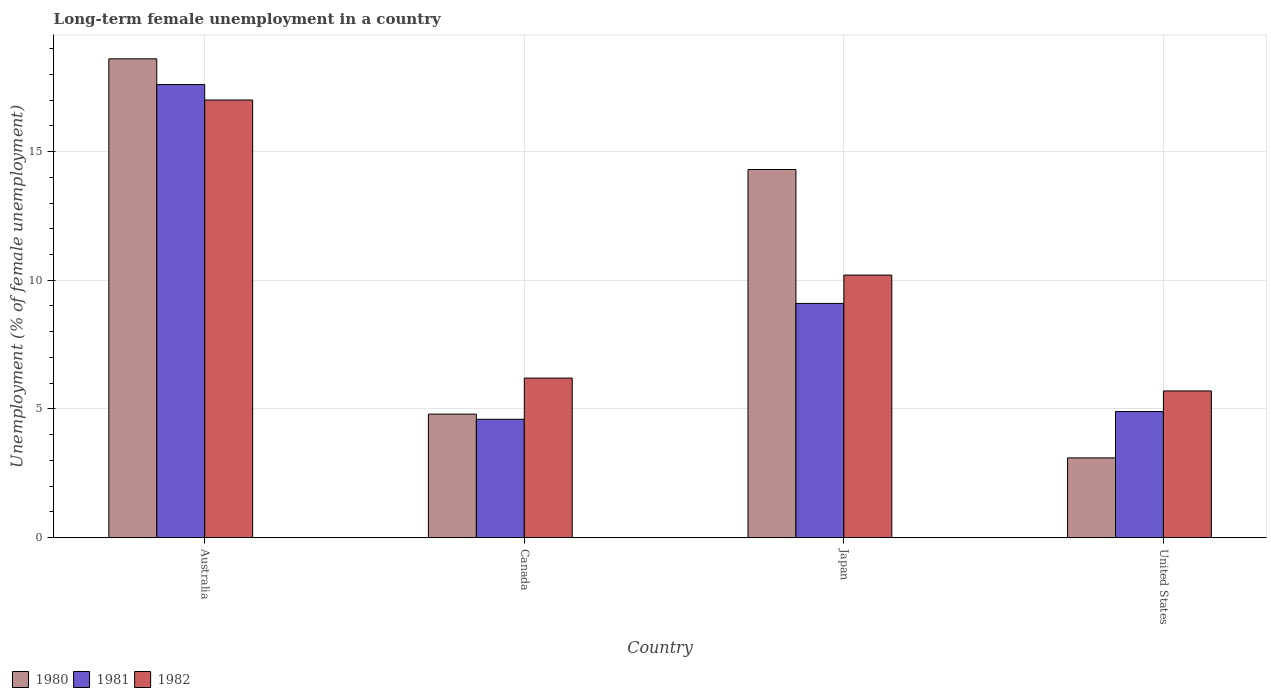How many different coloured bars are there?
Offer a very short reply. 3. Are the number of bars on each tick of the X-axis equal?
Your response must be concise. Yes. What is the label of the 1st group of bars from the left?
Your response must be concise. Australia. What is the percentage of long-term unemployed female population in 1981 in Canada?
Ensure brevity in your answer.  4.6. Across all countries, what is the maximum percentage of long-term unemployed female population in 1980?
Offer a terse response. 18.6. Across all countries, what is the minimum percentage of long-term unemployed female population in 1980?
Offer a very short reply. 3.1. In which country was the percentage of long-term unemployed female population in 1981 maximum?
Ensure brevity in your answer.  Australia. What is the total percentage of long-term unemployed female population in 1982 in the graph?
Offer a terse response. 39.1. What is the difference between the percentage of long-term unemployed female population in 1980 in Japan and that in United States?
Make the answer very short. 11.2. What is the difference between the percentage of long-term unemployed female population in 1981 in United States and the percentage of long-term unemployed female population in 1982 in Canada?
Provide a short and direct response. -1.3. What is the average percentage of long-term unemployed female population in 1980 per country?
Provide a short and direct response. 10.2. What is the difference between the percentage of long-term unemployed female population of/in 1982 and percentage of long-term unemployed female population of/in 1981 in Canada?
Make the answer very short. 1.6. In how many countries, is the percentage of long-term unemployed female population in 1981 greater than 2 %?
Make the answer very short. 4. What is the ratio of the percentage of long-term unemployed female population in 1982 in Canada to that in United States?
Provide a succinct answer. 1.09. Is the difference between the percentage of long-term unemployed female population in 1982 in Canada and Japan greater than the difference between the percentage of long-term unemployed female population in 1981 in Canada and Japan?
Ensure brevity in your answer.  Yes. What is the difference between the highest and the second highest percentage of long-term unemployed female population in 1982?
Make the answer very short. 6.8. What is the difference between the highest and the lowest percentage of long-term unemployed female population in 1982?
Your answer should be compact. 11.3. In how many countries, is the percentage of long-term unemployed female population in 1982 greater than the average percentage of long-term unemployed female population in 1982 taken over all countries?
Offer a terse response. 2. Is the sum of the percentage of long-term unemployed female population in 1982 in Japan and United States greater than the maximum percentage of long-term unemployed female population in 1981 across all countries?
Give a very brief answer. No. What does the 3rd bar from the right in Canada represents?
Your response must be concise. 1980. Does the graph contain grids?
Provide a short and direct response. Yes. How many legend labels are there?
Ensure brevity in your answer.  3. How are the legend labels stacked?
Offer a very short reply. Horizontal. What is the title of the graph?
Your answer should be compact. Long-term female unemployment in a country. Does "1982" appear as one of the legend labels in the graph?
Offer a terse response. Yes. What is the label or title of the Y-axis?
Make the answer very short. Unemployment (% of female unemployment). What is the Unemployment (% of female unemployment) of 1980 in Australia?
Your answer should be compact. 18.6. What is the Unemployment (% of female unemployment) of 1981 in Australia?
Your answer should be very brief. 17.6. What is the Unemployment (% of female unemployment) of 1982 in Australia?
Offer a very short reply. 17. What is the Unemployment (% of female unemployment) of 1980 in Canada?
Offer a terse response. 4.8. What is the Unemployment (% of female unemployment) of 1981 in Canada?
Provide a succinct answer. 4.6. What is the Unemployment (% of female unemployment) in 1982 in Canada?
Your answer should be compact. 6.2. What is the Unemployment (% of female unemployment) in 1980 in Japan?
Give a very brief answer. 14.3. What is the Unemployment (% of female unemployment) of 1981 in Japan?
Your answer should be compact. 9.1. What is the Unemployment (% of female unemployment) of 1982 in Japan?
Ensure brevity in your answer.  10.2. What is the Unemployment (% of female unemployment) of 1980 in United States?
Your response must be concise. 3.1. What is the Unemployment (% of female unemployment) of 1981 in United States?
Give a very brief answer. 4.9. What is the Unemployment (% of female unemployment) of 1982 in United States?
Your response must be concise. 5.7. Across all countries, what is the maximum Unemployment (% of female unemployment) of 1980?
Offer a very short reply. 18.6. Across all countries, what is the maximum Unemployment (% of female unemployment) in 1981?
Provide a succinct answer. 17.6. Across all countries, what is the minimum Unemployment (% of female unemployment) in 1980?
Provide a short and direct response. 3.1. Across all countries, what is the minimum Unemployment (% of female unemployment) in 1981?
Provide a succinct answer. 4.6. Across all countries, what is the minimum Unemployment (% of female unemployment) of 1982?
Give a very brief answer. 5.7. What is the total Unemployment (% of female unemployment) of 1980 in the graph?
Give a very brief answer. 40.8. What is the total Unemployment (% of female unemployment) of 1981 in the graph?
Keep it short and to the point. 36.2. What is the total Unemployment (% of female unemployment) in 1982 in the graph?
Offer a very short reply. 39.1. What is the difference between the Unemployment (% of female unemployment) of 1980 in Australia and that in Japan?
Your response must be concise. 4.3. What is the difference between the Unemployment (% of female unemployment) in 1980 in Australia and that in United States?
Your answer should be very brief. 15.5. What is the difference between the Unemployment (% of female unemployment) in 1980 in Canada and that in Japan?
Give a very brief answer. -9.5. What is the difference between the Unemployment (% of female unemployment) of 1981 in Canada and that in Japan?
Provide a succinct answer. -4.5. What is the difference between the Unemployment (% of female unemployment) in 1982 in Canada and that in Japan?
Give a very brief answer. -4. What is the difference between the Unemployment (% of female unemployment) of 1982 in Canada and that in United States?
Offer a terse response. 0.5. What is the difference between the Unemployment (% of female unemployment) of 1982 in Japan and that in United States?
Provide a succinct answer. 4.5. What is the difference between the Unemployment (% of female unemployment) in 1980 in Australia and the Unemployment (% of female unemployment) in 1981 in Canada?
Provide a succinct answer. 14. What is the difference between the Unemployment (% of female unemployment) in 1981 in Australia and the Unemployment (% of female unemployment) in 1982 in Canada?
Your answer should be very brief. 11.4. What is the difference between the Unemployment (% of female unemployment) in 1980 in Australia and the Unemployment (% of female unemployment) in 1981 in Japan?
Your answer should be very brief. 9.5. What is the difference between the Unemployment (% of female unemployment) in 1980 in Australia and the Unemployment (% of female unemployment) in 1982 in Japan?
Provide a short and direct response. 8.4. What is the difference between the Unemployment (% of female unemployment) in 1980 in Australia and the Unemployment (% of female unemployment) in 1981 in United States?
Make the answer very short. 13.7. What is the difference between the Unemployment (% of female unemployment) of 1980 in Australia and the Unemployment (% of female unemployment) of 1982 in United States?
Keep it short and to the point. 12.9. What is the difference between the Unemployment (% of female unemployment) of 1981 in Australia and the Unemployment (% of female unemployment) of 1982 in United States?
Offer a very short reply. 11.9. What is the difference between the Unemployment (% of female unemployment) of 1980 in Canada and the Unemployment (% of female unemployment) of 1981 in Japan?
Give a very brief answer. -4.3. What is the difference between the Unemployment (% of female unemployment) of 1980 in Canada and the Unemployment (% of female unemployment) of 1982 in Japan?
Your response must be concise. -5.4. What is the difference between the Unemployment (% of female unemployment) in 1981 in Canada and the Unemployment (% of female unemployment) in 1982 in Japan?
Give a very brief answer. -5.6. What is the average Unemployment (% of female unemployment) in 1980 per country?
Give a very brief answer. 10.2. What is the average Unemployment (% of female unemployment) in 1981 per country?
Provide a succinct answer. 9.05. What is the average Unemployment (% of female unemployment) in 1982 per country?
Your answer should be compact. 9.78. What is the difference between the Unemployment (% of female unemployment) of 1980 and Unemployment (% of female unemployment) of 1981 in Australia?
Provide a succinct answer. 1. What is the difference between the Unemployment (% of female unemployment) in 1981 and Unemployment (% of female unemployment) in 1982 in Australia?
Offer a very short reply. 0.6. What is the difference between the Unemployment (% of female unemployment) in 1980 and Unemployment (% of female unemployment) in 1982 in Canada?
Your answer should be compact. -1.4. What is the difference between the Unemployment (% of female unemployment) of 1981 and Unemployment (% of female unemployment) of 1982 in Canada?
Keep it short and to the point. -1.6. What is the difference between the Unemployment (% of female unemployment) in 1980 and Unemployment (% of female unemployment) in 1981 in Japan?
Make the answer very short. 5.2. What is the difference between the Unemployment (% of female unemployment) in 1981 and Unemployment (% of female unemployment) in 1982 in Japan?
Keep it short and to the point. -1.1. What is the difference between the Unemployment (% of female unemployment) of 1980 and Unemployment (% of female unemployment) of 1982 in United States?
Provide a short and direct response. -2.6. What is the ratio of the Unemployment (% of female unemployment) in 1980 in Australia to that in Canada?
Ensure brevity in your answer.  3.88. What is the ratio of the Unemployment (% of female unemployment) of 1981 in Australia to that in Canada?
Provide a short and direct response. 3.83. What is the ratio of the Unemployment (% of female unemployment) in 1982 in Australia to that in Canada?
Make the answer very short. 2.74. What is the ratio of the Unemployment (% of female unemployment) of 1980 in Australia to that in Japan?
Offer a terse response. 1.3. What is the ratio of the Unemployment (% of female unemployment) of 1981 in Australia to that in Japan?
Your answer should be very brief. 1.93. What is the ratio of the Unemployment (% of female unemployment) in 1982 in Australia to that in Japan?
Give a very brief answer. 1.67. What is the ratio of the Unemployment (% of female unemployment) in 1981 in Australia to that in United States?
Your response must be concise. 3.59. What is the ratio of the Unemployment (% of female unemployment) of 1982 in Australia to that in United States?
Offer a very short reply. 2.98. What is the ratio of the Unemployment (% of female unemployment) in 1980 in Canada to that in Japan?
Keep it short and to the point. 0.34. What is the ratio of the Unemployment (% of female unemployment) in 1981 in Canada to that in Japan?
Provide a short and direct response. 0.51. What is the ratio of the Unemployment (% of female unemployment) of 1982 in Canada to that in Japan?
Your answer should be compact. 0.61. What is the ratio of the Unemployment (% of female unemployment) of 1980 in Canada to that in United States?
Your response must be concise. 1.55. What is the ratio of the Unemployment (% of female unemployment) of 1981 in Canada to that in United States?
Offer a very short reply. 0.94. What is the ratio of the Unemployment (% of female unemployment) in 1982 in Canada to that in United States?
Ensure brevity in your answer.  1.09. What is the ratio of the Unemployment (% of female unemployment) of 1980 in Japan to that in United States?
Your answer should be compact. 4.61. What is the ratio of the Unemployment (% of female unemployment) of 1981 in Japan to that in United States?
Your answer should be compact. 1.86. What is the ratio of the Unemployment (% of female unemployment) of 1982 in Japan to that in United States?
Make the answer very short. 1.79. What is the difference between the highest and the second highest Unemployment (% of female unemployment) in 1981?
Make the answer very short. 8.5. What is the difference between the highest and the lowest Unemployment (% of female unemployment) in 1980?
Your answer should be very brief. 15.5. What is the difference between the highest and the lowest Unemployment (% of female unemployment) of 1981?
Give a very brief answer. 13. 